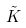Convert formula to latex. <formula><loc_0><loc_0><loc_500><loc_500>\tilde { K }</formula> 